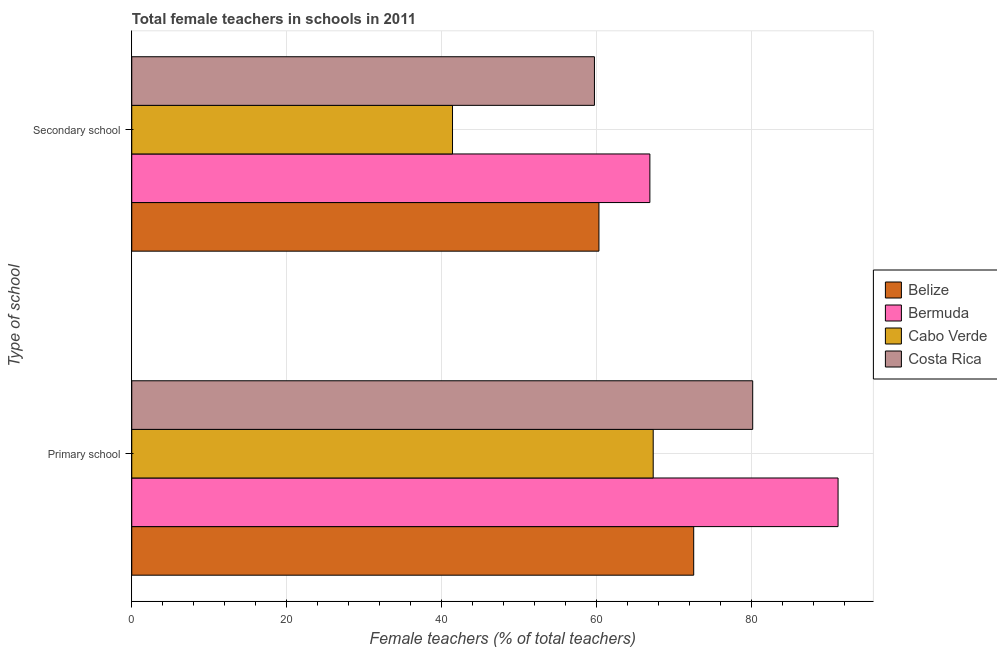How many groups of bars are there?
Provide a succinct answer. 2. Are the number of bars per tick equal to the number of legend labels?
Your response must be concise. Yes. How many bars are there on the 1st tick from the bottom?
Offer a very short reply. 4. What is the label of the 1st group of bars from the top?
Offer a very short reply. Secondary school. What is the percentage of female teachers in primary schools in Bermuda?
Make the answer very short. 91.15. Across all countries, what is the maximum percentage of female teachers in primary schools?
Your answer should be very brief. 91.15. Across all countries, what is the minimum percentage of female teachers in primary schools?
Provide a succinct answer. 67.29. In which country was the percentage of female teachers in primary schools maximum?
Your answer should be very brief. Bermuda. In which country was the percentage of female teachers in secondary schools minimum?
Provide a short and direct response. Cabo Verde. What is the total percentage of female teachers in secondary schools in the graph?
Make the answer very short. 228.26. What is the difference between the percentage of female teachers in primary schools in Cabo Verde and that in Belize?
Make the answer very short. -5.23. What is the difference between the percentage of female teachers in secondary schools in Costa Rica and the percentage of female teachers in primary schools in Bermuda?
Keep it short and to the point. -31.44. What is the average percentage of female teachers in primary schools per country?
Provide a short and direct response. 77.78. What is the difference between the percentage of female teachers in primary schools and percentage of female teachers in secondary schools in Belize?
Keep it short and to the point. 12.23. In how many countries, is the percentage of female teachers in secondary schools greater than 88 %?
Provide a short and direct response. 0. What is the ratio of the percentage of female teachers in primary schools in Costa Rica to that in Belize?
Provide a short and direct response. 1.1. In how many countries, is the percentage of female teachers in secondary schools greater than the average percentage of female teachers in secondary schools taken over all countries?
Make the answer very short. 3. What does the 2nd bar from the top in Secondary school represents?
Your response must be concise. Cabo Verde. What does the 1st bar from the bottom in Primary school represents?
Your answer should be compact. Belize. How many bars are there?
Provide a succinct answer. 8. How many countries are there in the graph?
Your answer should be very brief. 4. What is the difference between two consecutive major ticks on the X-axis?
Give a very brief answer. 20. Does the graph contain any zero values?
Provide a succinct answer. No. Where does the legend appear in the graph?
Your answer should be very brief. Center right. How are the legend labels stacked?
Your response must be concise. Vertical. What is the title of the graph?
Your response must be concise. Total female teachers in schools in 2011. What is the label or title of the X-axis?
Keep it short and to the point. Female teachers (% of total teachers). What is the label or title of the Y-axis?
Provide a succinct answer. Type of school. What is the Female teachers (% of total teachers) of Belize in Primary school?
Provide a succinct answer. 72.52. What is the Female teachers (% of total teachers) in Bermuda in Primary school?
Your answer should be very brief. 91.15. What is the Female teachers (% of total teachers) in Cabo Verde in Primary school?
Offer a very short reply. 67.29. What is the Female teachers (% of total teachers) in Costa Rica in Primary school?
Offer a terse response. 80.14. What is the Female teachers (% of total teachers) in Belize in Secondary school?
Make the answer very short. 60.29. What is the Female teachers (% of total teachers) in Bermuda in Secondary school?
Your answer should be very brief. 66.87. What is the Female teachers (% of total teachers) of Cabo Verde in Secondary school?
Your answer should be compact. 41.39. What is the Female teachers (% of total teachers) in Costa Rica in Secondary school?
Your answer should be compact. 59.71. Across all Type of school, what is the maximum Female teachers (% of total teachers) in Belize?
Make the answer very short. 72.52. Across all Type of school, what is the maximum Female teachers (% of total teachers) of Bermuda?
Provide a succinct answer. 91.15. Across all Type of school, what is the maximum Female teachers (% of total teachers) in Cabo Verde?
Your answer should be compact. 67.29. Across all Type of school, what is the maximum Female teachers (% of total teachers) in Costa Rica?
Provide a short and direct response. 80.14. Across all Type of school, what is the minimum Female teachers (% of total teachers) of Belize?
Make the answer very short. 60.29. Across all Type of school, what is the minimum Female teachers (% of total teachers) of Bermuda?
Your response must be concise. 66.87. Across all Type of school, what is the minimum Female teachers (% of total teachers) of Cabo Verde?
Offer a very short reply. 41.39. Across all Type of school, what is the minimum Female teachers (% of total teachers) in Costa Rica?
Make the answer very short. 59.71. What is the total Female teachers (% of total teachers) in Belize in the graph?
Ensure brevity in your answer.  132.81. What is the total Female teachers (% of total teachers) in Bermuda in the graph?
Provide a short and direct response. 158.02. What is the total Female teachers (% of total teachers) in Cabo Verde in the graph?
Your answer should be very brief. 108.69. What is the total Female teachers (% of total teachers) of Costa Rica in the graph?
Your answer should be compact. 139.85. What is the difference between the Female teachers (% of total teachers) of Belize in Primary school and that in Secondary school?
Keep it short and to the point. 12.23. What is the difference between the Female teachers (% of total teachers) of Bermuda in Primary school and that in Secondary school?
Your response must be concise. 24.29. What is the difference between the Female teachers (% of total teachers) of Cabo Verde in Primary school and that in Secondary school?
Ensure brevity in your answer.  25.9. What is the difference between the Female teachers (% of total teachers) in Costa Rica in Primary school and that in Secondary school?
Offer a very short reply. 20.43. What is the difference between the Female teachers (% of total teachers) of Belize in Primary school and the Female teachers (% of total teachers) of Bermuda in Secondary school?
Make the answer very short. 5.66. What is the difference between the Female teachers (% of total teachers) of Belize in Primary school and the Female teachers (% of total teachers) of Cabo Verde in Secondary school?
Make the answer very short. 31.13. What is the difference between the Female teachers (% of total teachers) in Belize in Primary school and the Female teachers (% of total teachers) in Costa Rica in Secondary school?
Offer a very short reply. 12.81. What is the difference between the Female teachers (% of total teachers) of Bermuda in Primary school and the Female teachers (% of total teachers) of Cabo Verde in Secondary school?
Keep it short and to the point. 49.76. What is the difference between the Female teachers (% of total teachers) of Bermuda in Primary school and the Female teachers (% of total teachers) of Costa Rica in Secondary school?
Your response must be concise. 31.44. What is the difference between the Female teachers (% of total teachers) in Cabo Verde in Primary school and the Female teachers (% of total teachers) in Costa Rica in Secondary school?
Make the answer very short. 7.58. What is the average Female teachers (% of total teachers) in Belize per Type of school?
Your answer should be very brief. 66.41. What is the average Female teachers (% of total teachers) of Bermuda per Type of school?
Ensure brevity in your answer.  79.01. What is the average Female teachers (% of total teachers) of Cabo Verde per Type of school?
Provide a short and direct response. 54.34. What is the average Female teachers (% of total teachers) in Costa Rica per Type of school?
Your response must be concise. 69.92. What is the difference between the Female teachers (% of total teachers) of Belize and Female teachers (% of total teachers) of Bermuda in Primary school?
Keep it short and to the point. -18.63. What is the difference between the Female teachers (% of total teachers) in Belize and Female teachers (% of total teachers) in Cabo Verde in Primary school?
Offer a terse response. 5.23. What is the difference between the Female teachers (% of total teachers) in Belize and Female teachers (% of total teachers) in Costa Rica in Primary school?
Ensure brevity in your answer.  -7.61. What is the difference between the Female teachers (% of total teachers) in Bermuda and Female teachers (% of total teachers) in Cabo Verde in Primary school?
Make the answer very short. 23.86. What is the difference between the Female teachers (% of total teachers) of Bermuda and Female teachers (% of total teachers) of Costa Rica in Primary school?
Offer a terse response. 11.02. What is the difference between the Female teachers (% of total teachers) of Cabo Verde and Female teachers (% of total teachers) of Costa Rica in Primary school?
Your answer should be very brief. -12.84. What is the difference between the Female teachers (% of total teachers) of Belize and Female teachers (% of total teachers) of Bermuda in Secondary school?
Give a very brief answer. -6.57. What is the difference between the Female teachers (% of total teachers) of Belize and Female teachers (% of total teachers) of Cabo Verde in Secondary school?
Your response must be concise. 18.9. What is the difference between the Female teachers (% of total teachers) of Belize and Female teachers (% of total teachers) of Costa Rica in Secondary school?
Provide a succinct answer. 0.58. What is the difference between the Female teachers (% of total teachers) of Bermuda and Female teachers (% of total teachers) of Cabo Verde in Secondary school?
Provide a short and direct response. 25.47. What is the difference between the Female teachers (% of total teachers) of Bermuda and Female teachers (% of total teachers) of Costa Rica in Secondary school?
Offer a very short reply. 7.16. What is the difference between the Female teachers (% of total teachers) in Cabo Verde and Female teachers (% of total teachers) in Costa Rica in Secondary school?
Make the answer very short. -18.32. What is the ratio of the Female teachers (% of total teachers) of Belize in Primary school to that in Secondary school?
Your response must be concise. 1.2. What is the ratio of the Female teachers (% of total teachers) in Bermuda in Primary school to that in Secondary school?
Make the answer very short. 1.36. What is the ratio of the Female teachers (% of total teachers) in Cabo Verde in Primary school to that in Secondary school?
Your answer should be very brief. 1.63. What is the ratio of the Female teachers (% of total teachers) in Costa Rica in Primary school to that in Secondary school?
Offer a terse response. 1.34. What is the difference between the highest and the second highest Female teachers (% of total teachers) of Belize?
Your answer should be compact. 12.23. What is the difference between the highest and the second highest Female teachers (% of total teachers) of Bermuda?
Your response must be concise. 24.29. What is the difference between the highest and the second highest Female teachers (% of total teachers) of Cabo Verde?
Provide a succinct answer. 25.9. What is the difference between the highest and the second highest Female teachers (% of total teachers) in Costa Rica?
Your answer should be compact. 20.43. What is the difference between the highest and the lowest Female teachers (% of total teachers) of Belize?
Provide a succinct answer. 12.23. What is the difference between the highest and the lowest Female teachers (% of total teachers) in Bermuda?
Your answer should be very brief. 24.29. What is the difference between the highest and the lowest Female teachers (% of total teachers) in Cabo Verde?
Provide a succinct answer. 25.9. What is the difference between the highest and the lowest Female teachers (% of total teachers) in Costa Rica?
Ensure brevity in your answer.  20.43. 